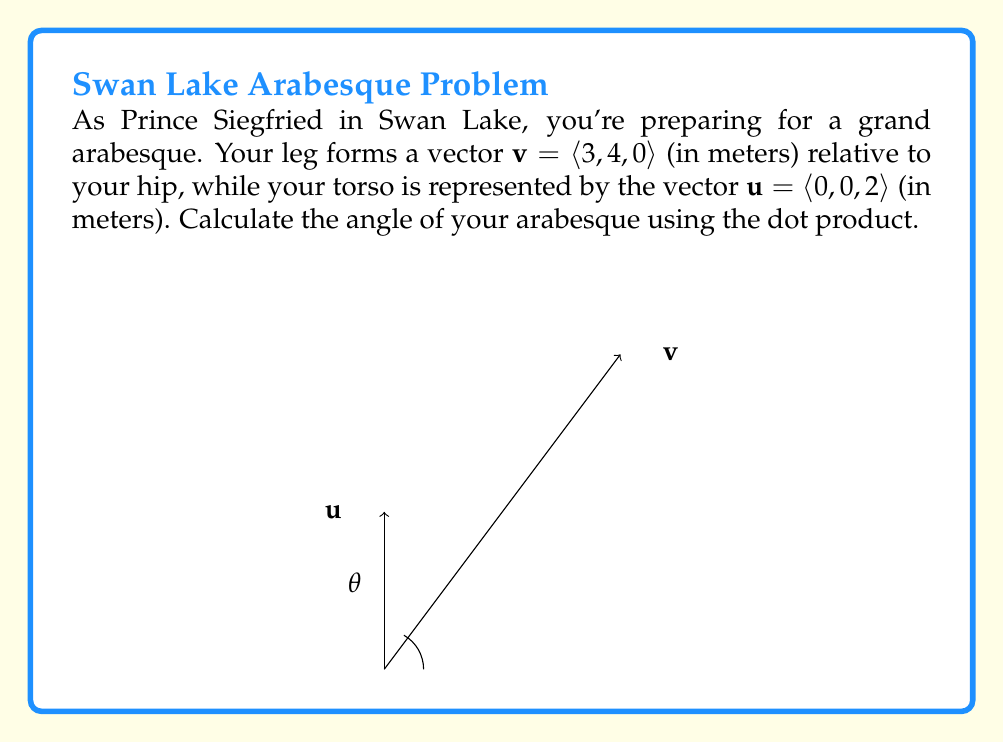Can you solve this math problem? To find the angle between two vectors using the dot product, we'll follow these steps:

1) The formula for the angle $\theta$ between two vectors $\mathbf{u}$ and $\mathbf{v}$ is:

   $$\cos \theta = \frac{\mathbf{u} \cdot \mathbf{v}}{|\mathbf{u}||\mathbf{v}|}$$

2) Calculate the dot product $\mathbf{u} \cdot \mathbf{v}$:
   $$\mathbf{u} \cdot \mathbf{v} = (0)(3) + (0)(4) + (2)(0) = 0$$

3) Calculate the magnitudes of the vectors:
   $$|\mathbf{u}| = \sqrt{0^2 + 0^2 + 2^2} = 2$$
   $$|\mathbf{v}| = \sqrt{3^2 + 4^2 + 0^2} = 5$$

4) Substitute into the formula:
   $$\cos \theta = \frac{0}{(2)(5)} = 0$$

5) Solve for $\theta$:
   $$\theta = \arccos(0) = \frac{\pi}{2} \text{ radians} = 90^\circ$$

Therefore, the angle of the arabesque is 90°.
Answer: 90° 